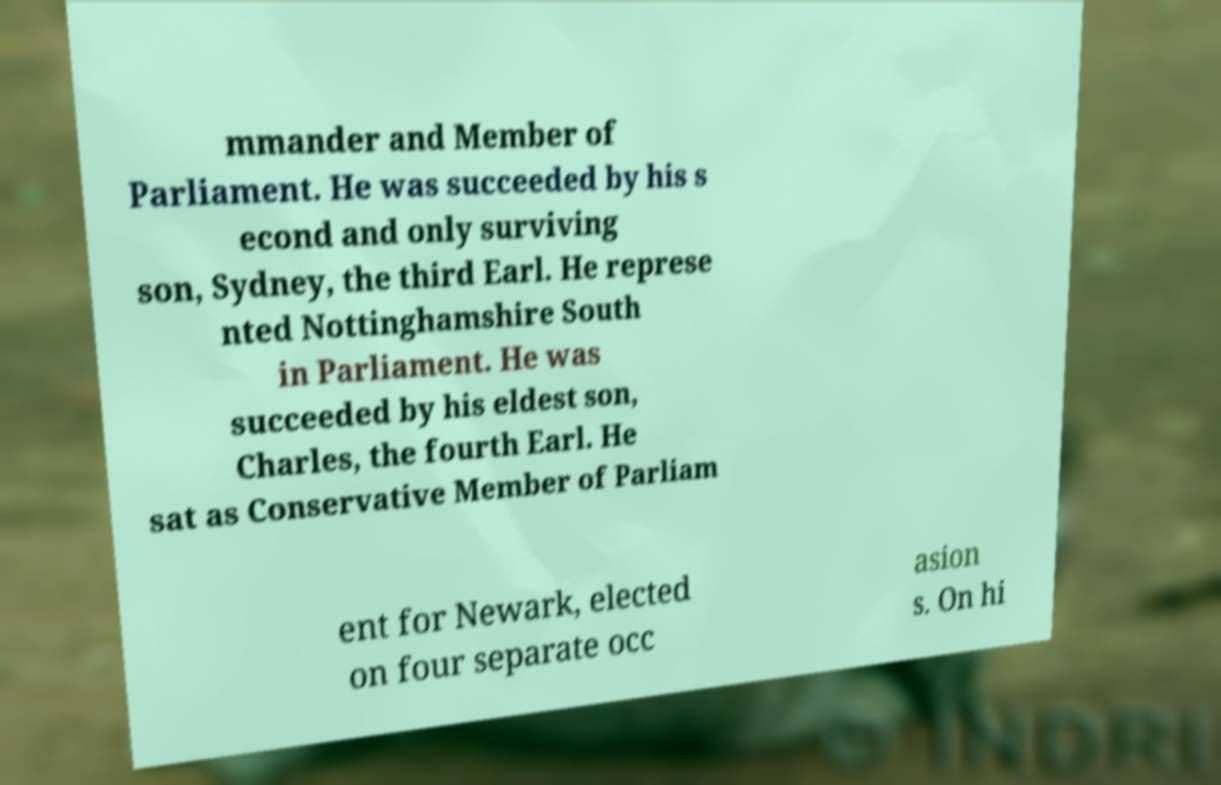There's text embedded in this image that I need extracted. Can you transcribe it verbatim? mmander and Member of Parliament. He was succeeded by his s econd and only surviving son, Sydney, the third Earl. He represe nted Nottinghamshire South in Parliament. He was succeeded by his eldest son, Charles, the fourth Earl. He sat as Conservative Member of Parliam ent for Newark, elected on four separate occ asion s. On hi 